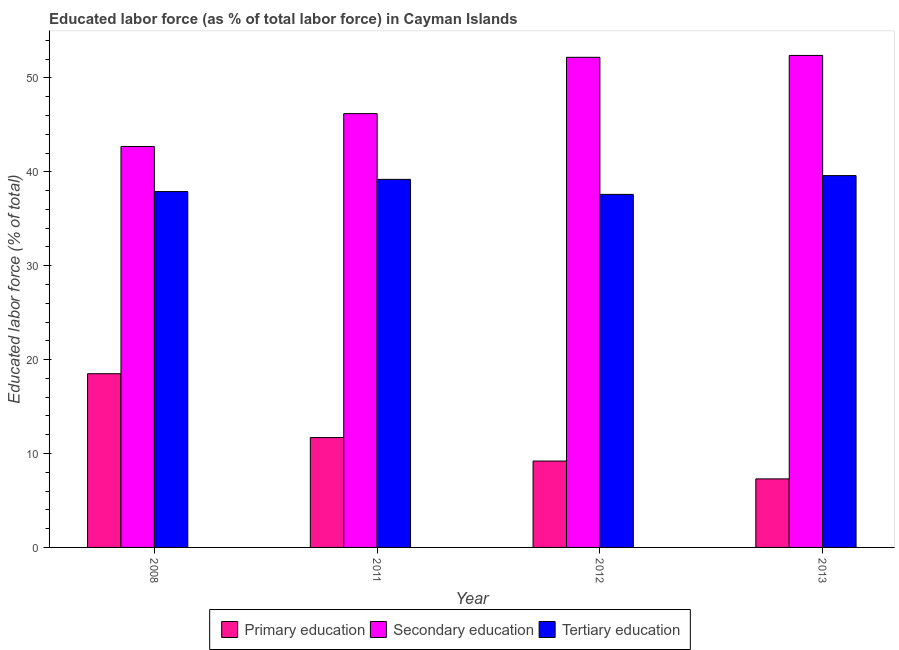How many different coloured bars are there?
Your answer should be compact. 3. How many groups of bars are there?
Ensure brevity in your answer.  4. Are the number of bars per tick equal to the number of legend labels?
Provide a succinct answer. Yes. In how many cases, is the number of bars for a given year not equal to the number of legend labels?
Offer a very short reply. 0. What is the percentage of labor force who received primary education in 2011?
Provide a succinct answer. 11.7. Across all years, what is the maximum percentage of labor force who received tertiary education?
Provide a short and direct response. 39.6. Across all years, what is the minimum percentage of labor force who received tertiary education?
Keep it short and to the point. 37.6. What is the total percentage of labor force who received primary education in the graph?
Give a very brief answer. 46.7. What is the difference between the percentage of labor force who received primary education in 2011 and that in 2012?
Make the answer very short. 2.5. What is the difference between the percentage of labor force who received tertiary education in 2011 and the percentage of labor force who received primary education in 2012?
Give a very brief answer. 1.6. What is the average percentage of labor force who received secondary education per year?
Give a very brief answer. 48.38. In the year 2013, what is the difference between the percentage of labor force who received secondary education and percentage of labor force who received primary education?
Your answer should be compact. 0. What is the ratio of the percentage of labor force who received secondary education in 2008 to that in 2013?
Give a very brief answer. 0.81. Is the percentage of labor force who received primary education in 2008 less than that in 2011?
Make the answer very short. No. What is the difference between the highest and the second highest percentage of labor force who received secondary education?
Your answer should be very brief. 0.2. What does the 3rd bar from the left in 2008 represents?
Your answer should be compact. Tertiary education. What does the 3rd bar from the right in 2011 represents?
Make the answer very short. Primary education. Is it the case that in every year, the sum of the percentage of labor force who received primary education and percentage of labor force who received secondary education is greater than the percentage of labor force who received tertiary education?
Make the answer very short. Yes. How many bars are there?
Give a very brief answer. 12. How many years are there in the graph?
Provide a short and direct response. 4. Where does the legend appear in the graph?
Your response must be concise. Bottom center. How many legend labels are there?
Ensure brevity in your answer.  3. What is the title of the graph?
Provide a succinct answer. Educated labor force (as % of total labor force) in Cayman Islands. What is the label or title of the Y-axis?
Your answer should be very brief. Educated labor force (% of total). What is the Educated labor force (% of total) of Primary education in 2008?
Offer a terse response. 18.5. What is the Educated labor force (% of total) in Secondary education in 2008?
Make the answer very short. 42.7. What is the Educated labor force (% of total) of Tertiary education in 2008?
Provide a succinct answer. 37.9. What is the Educated labor force (% of total) of Primary education in 2011?
Ensure brevity in your answer.  11.7. What is the Educated labor force (% of total) in Secondary education in 2011?
Keep it short and to the point. 46.2. What is the Educated labor force (% of total) in Tertiary education in 2011?
Your response must be concise. 39.2. What is the Educated labor force (% of total) in Primary education in 2012?
Ensure brevity in your answer.  9.2. What is the Educated labor force (% of total) in Secondary education in 2012?
Your response must be concise. 52.2. What is the Educated labor force (% of total) in Tertiary education in 2012?
Give a very brief answer. 37.6. What is the Educated labor force (% of total) in Primary education in 2013?
Ensure brevity in your answer.  7.3. What is the Educated labor force (% of total) of Secondary education in 2013?
Your answer should be compact. 52.4. What is the Educated labor force (% of total) of Tertiary education in 2013?
Provide a succinct answer. 39.6. Across all years, what is the maximum Educated labor force (% of total) of Primary education?
Offer a terse response. 18.5. Across all years, what is the maximum Educated labor force (% of total) in Secondary education?
Your response must be concise. 52.4. Across all years, what is the maximum Educated labor force (% of total) of Tertiary education?
Make the answer very short. 39.6. Across all years, what is the minimum Educated labor force (% of total) of Primary education?
Give a very brief answer. 7.3. Across all years, what is the minimum Educated labor force (% of total) of Secondary education?
Give a very brief answer. 42.7. Across all years, what is the minimum Educated labor force (% of total) in Tertiary education?
Provide a succinct answer. 37.6. What is the total Educated labor force (% of total) of Primary education in the graph?
Your response must be concise. 46.7. What is the total Educated labor force (% of total) of Secondary education in the graph?
Your answer should be very brief. 193.5. What is the total Educated labor force (% of total) of Tertiary education in the graph?
Your response must be concise. 154.3. What is the difference between the Educated labor force (% of total) of Primary education in 2008 and that in 2011?
Your answer should be very brief. 6.8. What is the difference between the Educated labor force (% of total) of Primary education in 2008 and that in 2012?
Provide a succinct answer. 9.3. What is the difference between the Educated labor force (% of total) of Secondary education in 2008 and that in 2012?
Provide a succinct answer. -9.5. What is the difference between the Educated labor force (% of total) in Tertiary education in 2008 and that in 2012?
Your answer should be compact. 0.3. What is the difference between the Educated labor force (% of total) in Primary education in 2008 and that in 2013?
Ensure brevity in your answer.  11.2. What is the difference between the Educated labor force (% of total) in Secondary education in 2008 and that in 2013?
Provide a short and direct response. -9.7. What is the difference between the Educated labor force (% of total) of Tertiary education in 2008 and that in 2013?
Make the answer very short. -1.7. What is the difference between the Educated labor force (% of total) in Primary education in 2011 and that in 2013?
Your answer should be very brief. 4.4. What is the difference between the Educated labor force (% of total) of Primary education in 2012 and that in 2013?
Your response must be concise. 1.9. What is the difference between the Educated labor force (% of total) in Primary education in 2008 and the Educated labor force (% of total) in Secondary education in 2011?
Your answer should be compact. -27.7. What is the difference between the Educated labor force (% of total) of Primary education in 2008 and the Educated labor force (% of total) of Tertiary education in 2011?
Provide a short and direct response. -20.7. What is the difference between the Educated labor force (% of total) in Secondary education in 2008 and the Educated labor force (% of total) in Tertiary education in 2011?
Ensure brevity in your answer.  3.5. What is the difference between the Educated labor force (% of total) in Primary education in 2008 and the Educated labor force (% of total) in Secondary education in 2012?
Your answer should be compact. -33.7. What is the difference between the Educated labor force (% of total) in Primary education in 2008 and the Educated labor force (% of total) in Tertiary education in 2012?
Give a very brief answer. -19.1. What is the difference between the Educated labor force (% of total) in Secondary education in 2008 and the Educated labor force (% of total) in Tertiary education in 2012?
Keep it short and to the point. 5.1. What is the difference between the Educated labor force (% of total) of Primary education in 2008 and the Educated labor force (% of total) of Secondary education in 2013?
Offer a very short reply. -33.9. What is the difference between the Educated labor force (% of total) of Primary education in 2008 and the Educated labor force (% of total) of Tertiary education in 2013?
Give a very brief answer. -21.1. What is the difference between the Educated labor force (% of total) of Secondary education in 2008 and the Educated labor force (% of total) of Tertiary education in 2013?
Your answer should be compact. 3.1. What is the difference between the Educated labor force (% of total) of Primary education in 2011 and the Educated labor force (% of total) of Secondary education in 2012?
Keep it short and to the point. -40.5. What is the difference between the Educated labor force (% of total) in Primary education in 2011 and the Educated labor force (% of total) in Tertiary education in 2012?
Keep it short and to the point. -25.9. What is the difference between the Educated labor force (% of total) in Primary education in 2011 and the Educated labor force (% of total) in Secondary education in 2013?
Provide a short and direct response. -40.7. What is the difference between the Educated labor force (% of total) of Primary education in 2011 and the Educated labor force (% of total) of Tertiary education in 2013?
Offer a very short reply. -27.9. What is the difference between the Educated labor force (% of total) in Secondary education in 2011 and the Educated labor force (% of total) in Tertiary education in 2013?
Offer a terse response. 6.6. What is the difference between the Educated labor force (% of total) of Primary education in 2012 and the Educated labor force (% of total) of Secondary education in 2013?
Ensure brevity in your answer.  -43.2. What is the difference between the Educated labor force (% of total) of Primary education in 2012 and the Educated labor force (% of total) of Tertiary education in 2013?
Provide a succinct answer. -30.4. What is the difference between the Educated labor force (% of total) of Secondary education in 2012 and the Educated labor force (% of total) of Tertiary education in 2013?
Make the answer very short. 12.6. What is the average Educated labor force (% of total) in Primary education per year?
Offer a very short reply. 11.68. What is the average Educated labor force (% of total) in Secondary education per year?
Your answer should be compact. 48.38. What is the average Educated labor force (% of total) of Tertiary education per year?
Your answer should be compact. 38.58. In the year 2008, what is the difference between the Educated labor force (% of total) of Primary education and Educated labor force (% of total) of Secondary education?
Provide a short and direct response. -24.2. In the year 2008, what is the difference between the Educated labor force (% of total) of Primary education and Educated labor force (% of total) of Tertiary education?
Ensure brevity in your answer.  -19.4. In the year 2011, what is the difference between the Educated labor force (% of total) in Primary education and Educated labor force (% of total) in Secondary education?
Your answer should be very brief. -34.5. In the year 2011, what is the difference between the Educated labor force (% of total) in Primary education and Educated labor force (% of total) in Tertiary education?
Offer a terse response. -27.5. In the year 2012, what is the difference between the Educated labor force (% of total) of Primary education and Educated labor force (% of total) of Secondary education?
Make the answer very short. -43. In the year 2012, what is the difference between the Educated labor force (% of total) of Primary education and Educated labor force (% of total) of Tertiary education?
Provide a short and direct response. -28.4. In the year 2012, what is the difference between the Educated labor force (% of total) of Secondary education and Educated labor force (% of total) of Tertiary education?
Your response must be concise. 14.6. In the year 2013, what is the difference between the Educated labor force (% of total) in Primary education and Educated labor force (% of total) in Secondary education?
Give a very brief answer. -45.1. In the year 2013, what is the difference between the Educated labor force (% of total) of Primary education and Educated labor force (% of total) of Tertiary education?
Ensure brevity in your answer.  -32.3. In the year 2013, what is the difference between the Educated labor force (% of total) in Secondary education and Educated labor force (% of total) in Tertiary education?
Offer a very short reply. 12.8. What is the ratio of the Educated labor force (% of total) in Primary education in 2008 to that in 2011?
Your answer should be very brief. 1.58. What is the ratio of the Educated labor force (% of total) of Secondary education in 2008 to that in 2011?
Offer a terse response. 0.92. What is the ratio of the Educated labor force (% of total) in Tertiary education in 2008 to that in 2011?
Your response must be concise. 0.97. What is the ratio of the Educated labor force (% of total) of Primary education in 2008 to that in 2012?
Ensure brevity in your answer.  2.01. What is the ratio of the Educated labor force (% of total) in Secondary education in 2008 to that in 2012?
Your response must be concise. 0.82. What is the ratio of the Educated labor force (% of total) of Tertiary education in 2008 to that in 2012?
Offer a terse response. 1.01. What is the ratio of the Educated labor force (% of total) of Primary education in 2008 to that in 2013?
Your response must be concise. 2.53. What is the ratio of the Educated labor force (% of total) in Secondary education in 2008 to that in 2013?
Your answer should be very brief. 0.81. What is the ratio of the Educated labor force (% of total) in Tertiary education in 2008 to that in 2013?
Make the answer very short. 0.96. What is the ratio of the Educated labor force (% of total) of Primary education in 2011 to that in 2012?
Offer a terse response. 1.27. What is the ratio of the Educated labor force (% of total) in Secondary education in 2011 to that in 2012?
Keep it short and to the point. 0.89. What is the ratio of the Educated labor force (% of total) of Tertiary education in 2011 to that in 2012?
Provide a short and direct response. 1.04. What is the ratio of the Educated labor force (% of total) of Primary education in 2011 to that in 2013?
Your answer should be very brief. 1.6. What is the ratio of the Educated labor force (% of total) of Secondary education in 2011 to that in 2013?
Keep it short and to the point. 0.88. What is the ratio of the Educated labor force (% of total) of Tertiary education in 2011 to that in 2013?
Your answer should be compact. 0.99. What is the ratio of the Educated labor force (% of total) of Primary education in 2012 to that in 2013?
Make the answer very short. 1.26. What is the ratio of the Educated labor force (% of total) in Tertiary education in 2012 to that in 2013?
Ensure brevity in your answer.  0.95. What is the difference between the highest and the second highest Educated labor force (% of total) of Primary education?
Ensure brevity in your answer.  6.8. What is the difference between the highest and the second highest Educated labor force (% of total) of Secondary education?
Keep it short and to the point. 0.2. What is the difference between the highest and the lowest Educated labor force (% of total) of Primary education?
Provide a succinct answer. 11.2. 